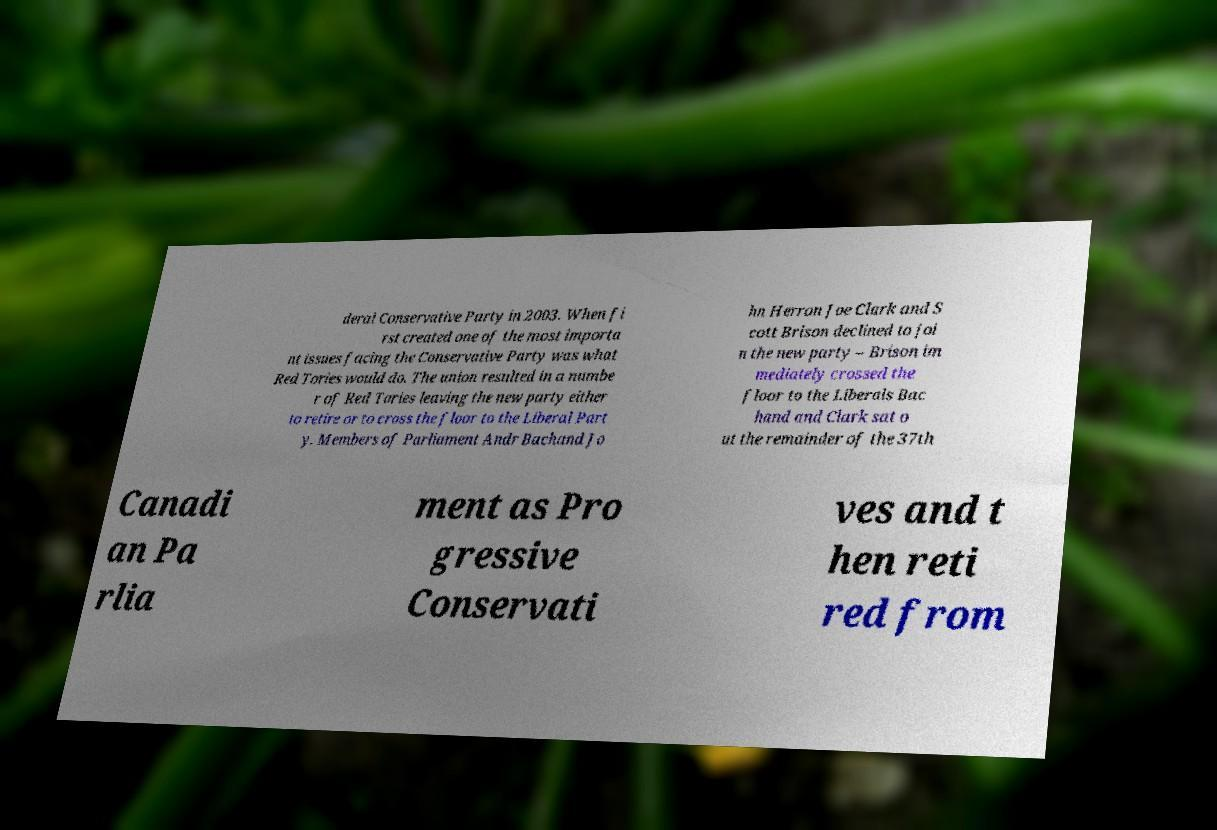Please read and relay the text visible in this image. What does it say? deral Conservative Party in 2003. When fi rst created one of the most importa nt issues facing the Conservative Party was what Red Tories would do. The union resulted in a numbe r of Red Tories leaving the new party either to retire or to cross the floor to the Liberal Part y. Members of Parliament Andr Bachand Jo hn Herron Joe Clark and S cott Brison declined to joi n the new party – Brison im mediately crossed the floor to the Liberals Bac hand and Clark sat o ut the remainder of the 37th Canadi an Pa rlia ment as Pro gressive Conservati ves and t hen reti red from 